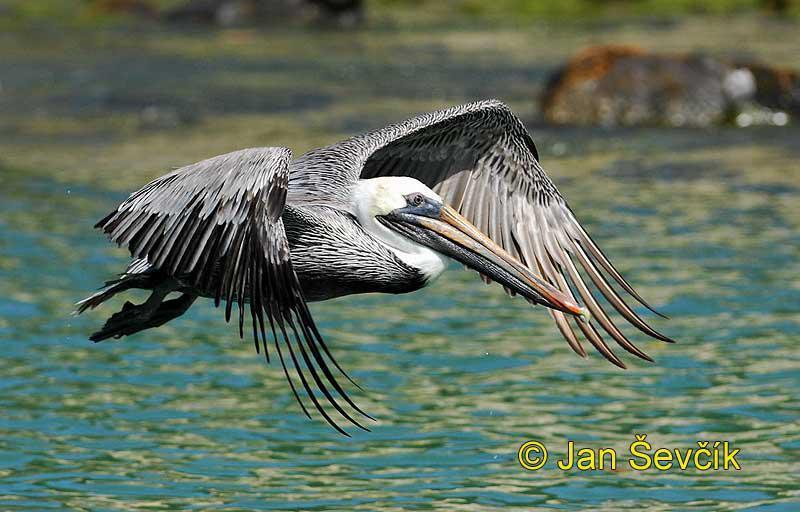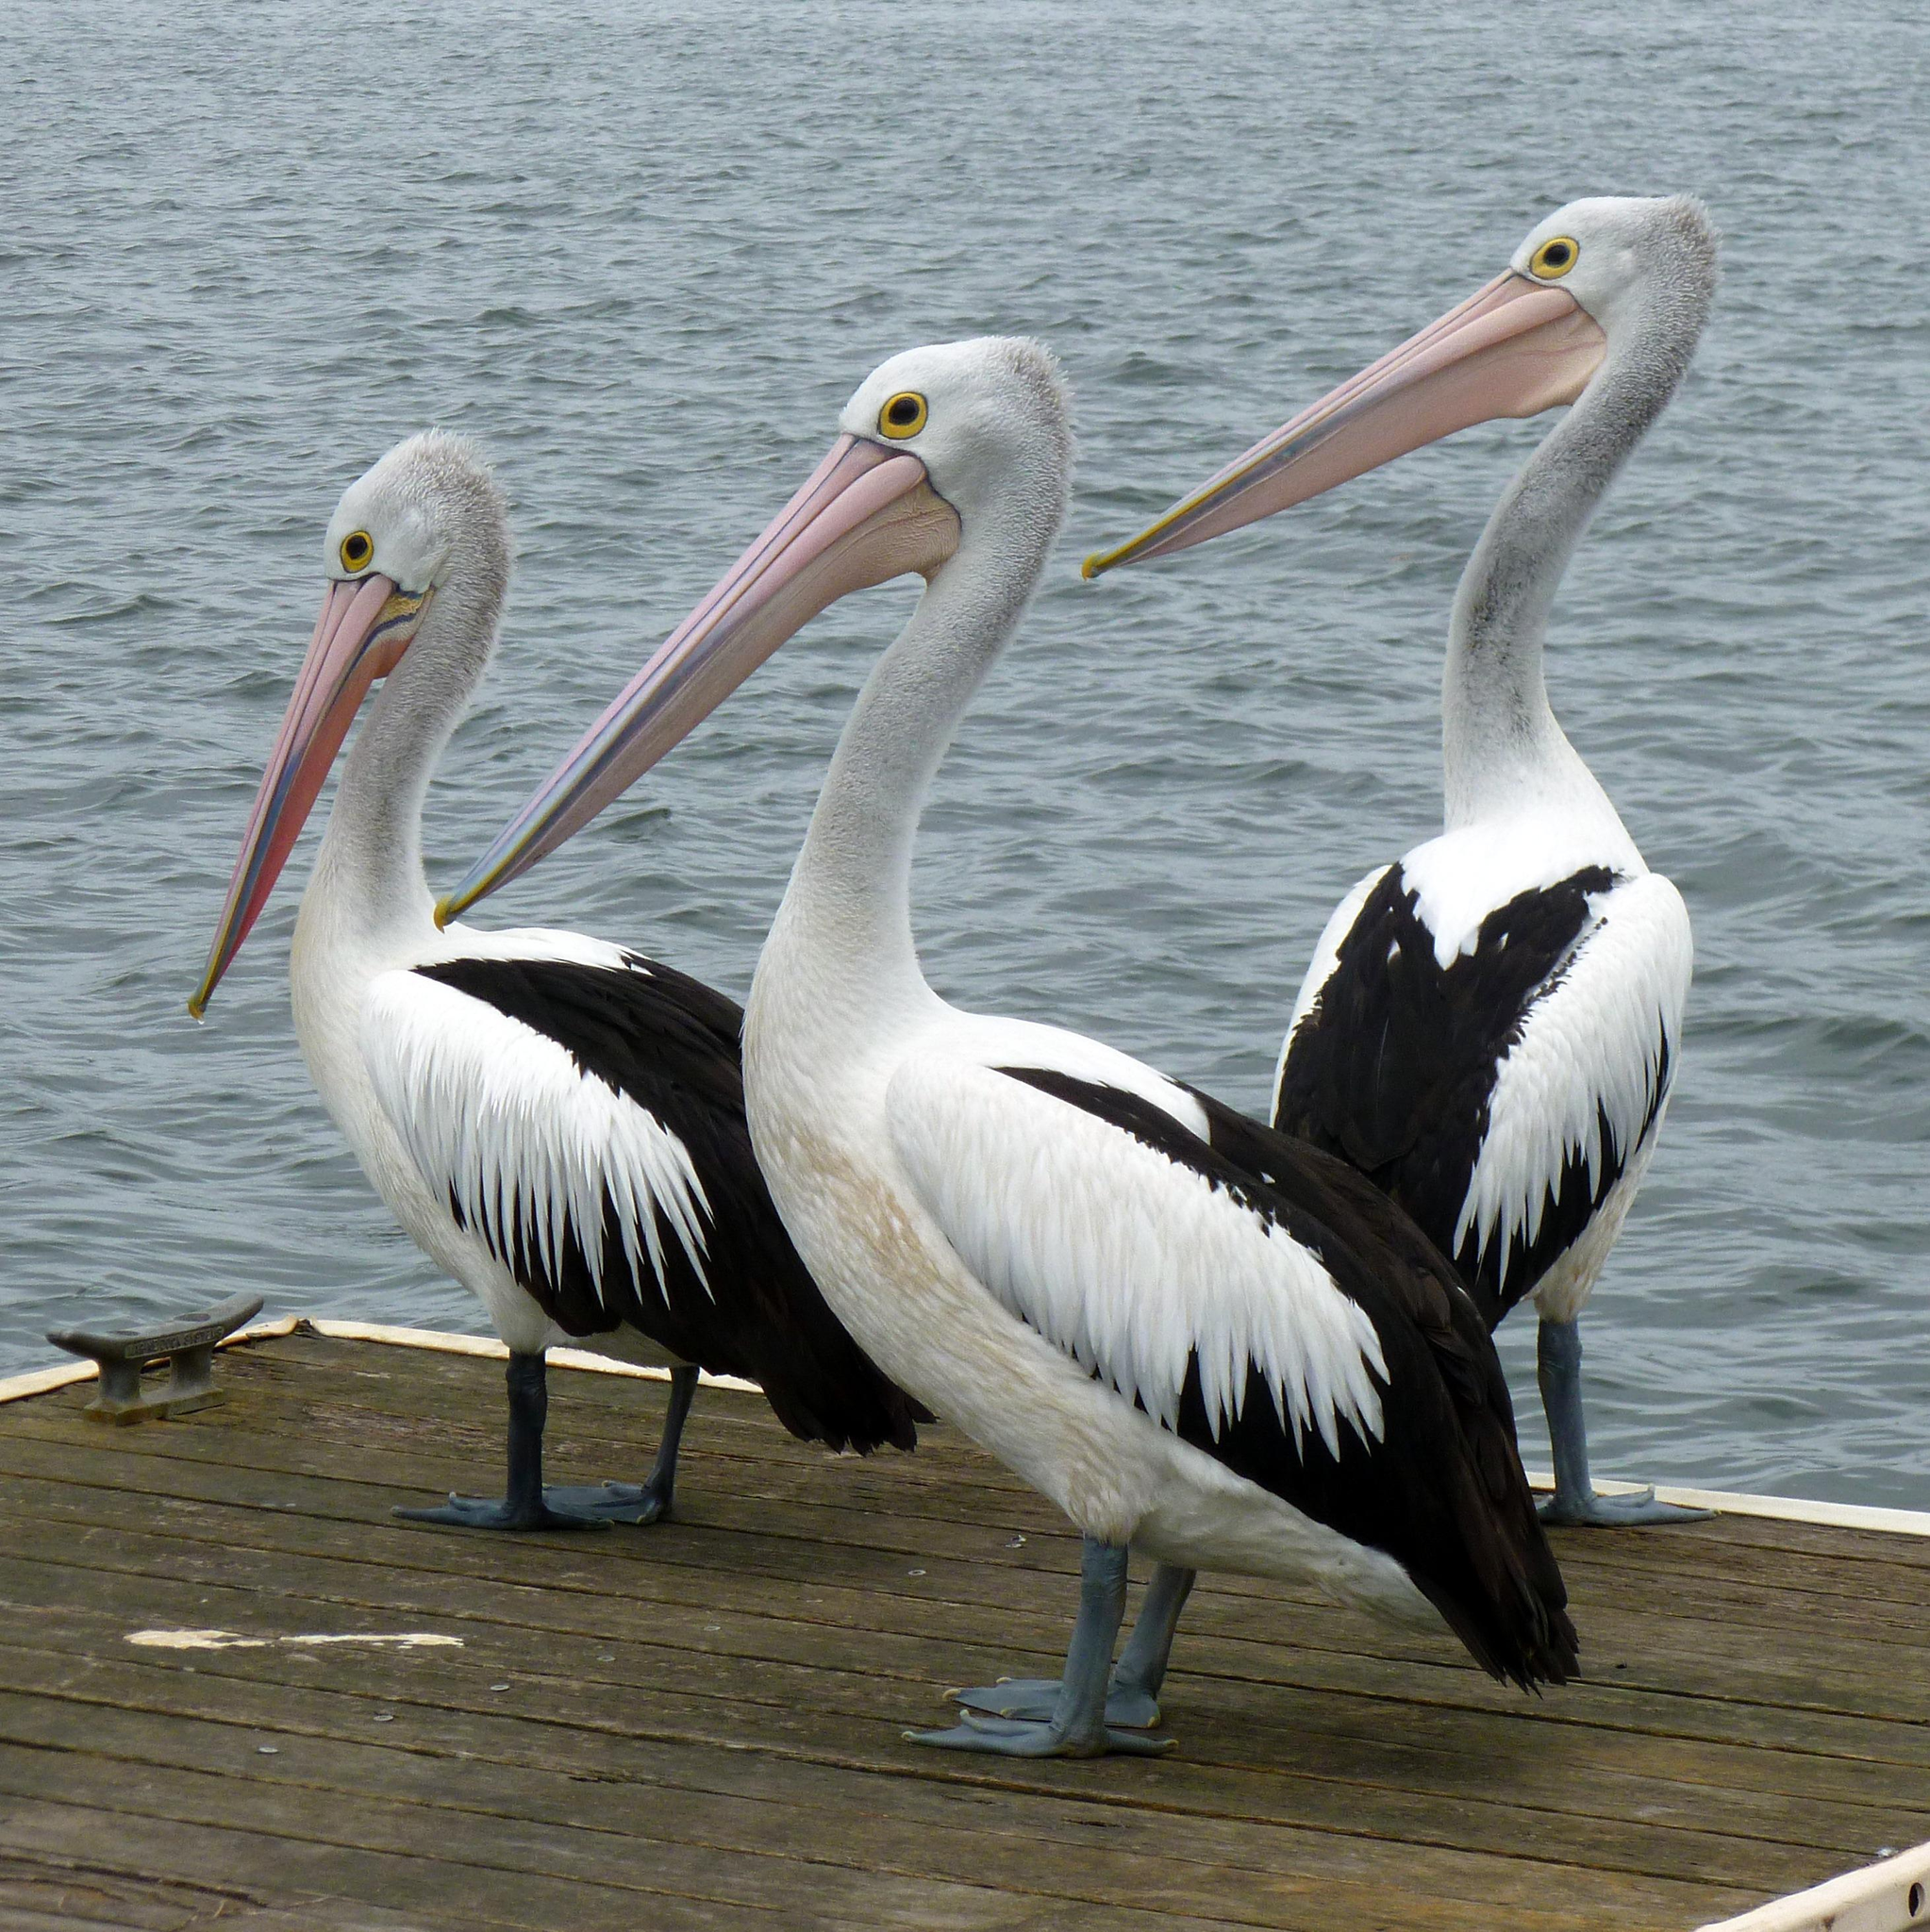The first image is the image on the left, the second image is the image on the right. Examine the images to the left and right. Is the description "One image shows three pelicans on the edge of a pier." accurate? Answer yes or no. Yes. The first image is the image on the left, the second image is the image on the right. Assess this claim about the two images: "There are no more than three pelicans". Correct or not? Answer yes or no. No. 